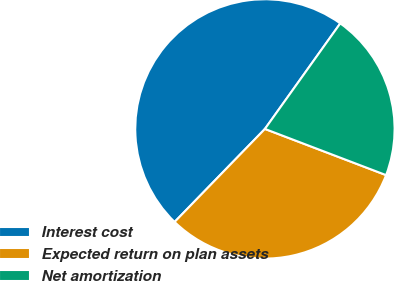<chart> <loc_0><loc_0><loc_500><loc_500><pie_chart><fcel>Interest cost<fcel>Expected return on plan assets<fcel>Net amortization<nl><fcel>47.6%<fcel>31.47%<fcel>20.93%<nl></chart> 